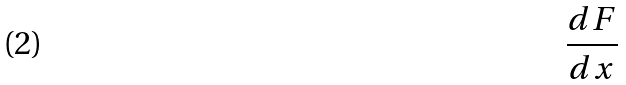<formula> <loc_0><loc_0><loc_500><loc_500>\frac { d F } { d x }</formula> 